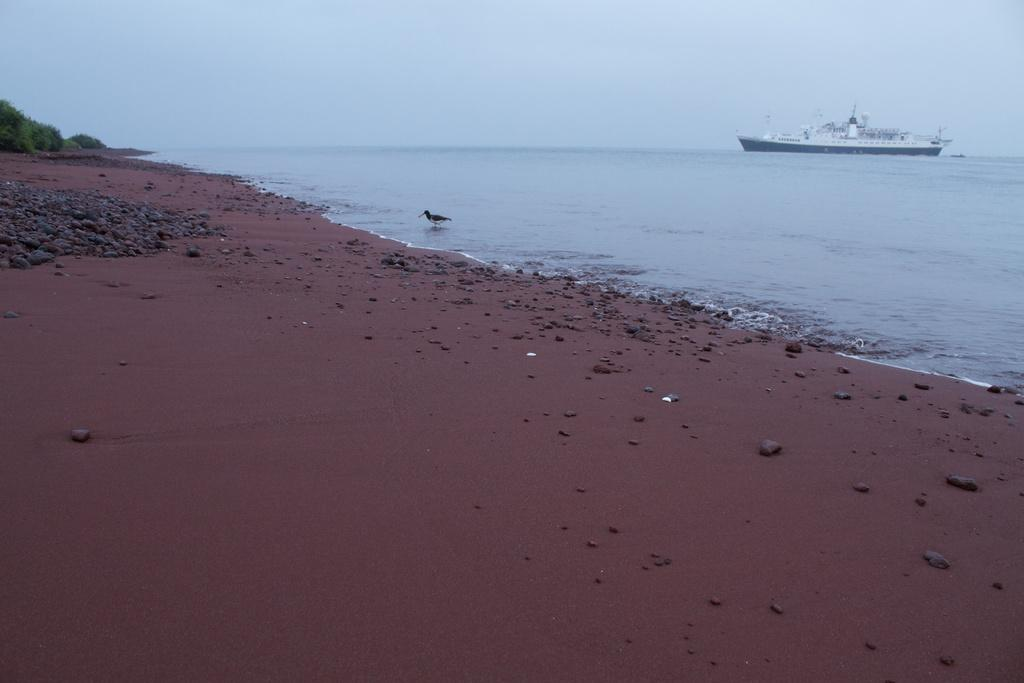What is the main subject of the image? There is a ship in the image. Where is the ship located? The ship is on the beach. Can you describe any other elements in the image? There is a bird at the sea shore. What type of instrument is the bird playing at the sea shore? There is no instrument present in the image, and the bird is not playing any instrument. 